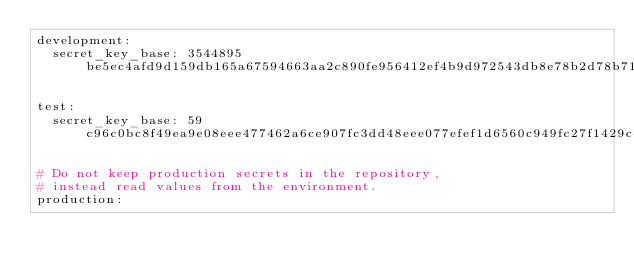<code> <loc_0><loc_0><loc_500><loc_500><_YAML_>development:
  secret_key_base: 3544895be5ec4afd9d159db165a67594663aa2c890fe956412ef4b9d972543db8e78b2d78b719bf466b3623e2fdcb9c862ef94d4dd12809e286266f61529ede0

test:
  secret_key_base: 59c96c0bc8f49ea9e08eee477462a6ce907fc3dd48eee077efef1d6560c949fc27f1429c4d76320a3285447295bd4337d0e2bc9f8e56fe834d65e12a8ae9217e

# Do not keep production secrets in the repository,
# instead read values from the environment.
production:</code> 